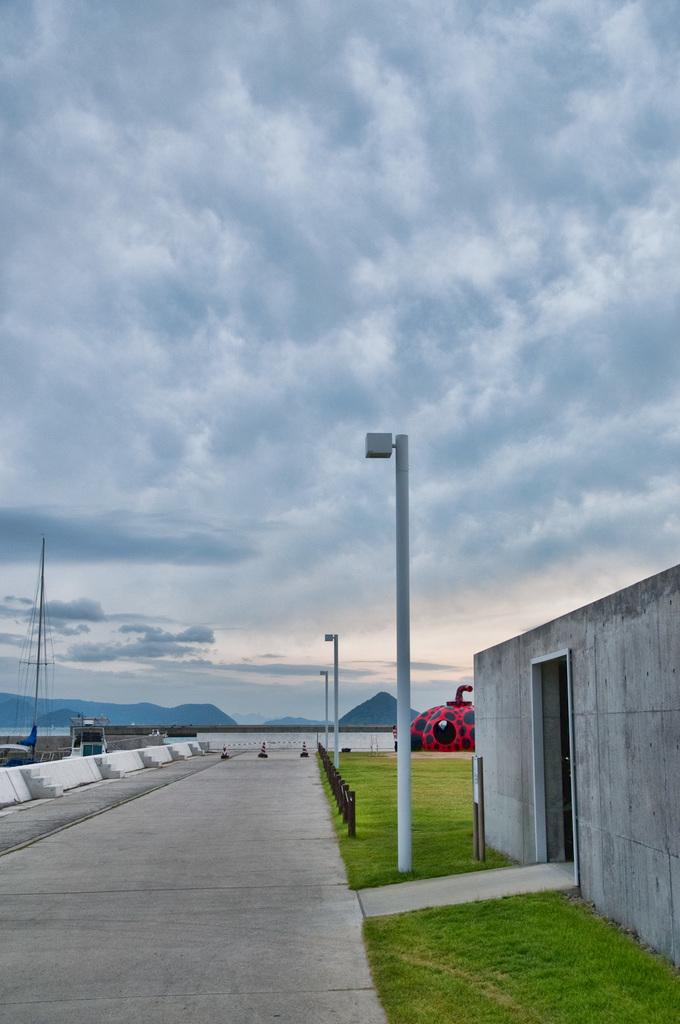What structures can be seen in the image? There are poles and wires in the image. What type of vegetation is visible in the image? There is grass visible in the image. What color is the prominent object in the image? There is a red color thing in the image. What can be seen in the sky in the image? Clouds and the sky are visible in the image. What verse is being recited by the alarm in the image? There is no alarm or verse present in the image. How does the grass fall in the image? Grass does not fall; it is a stationary plant in the image. 